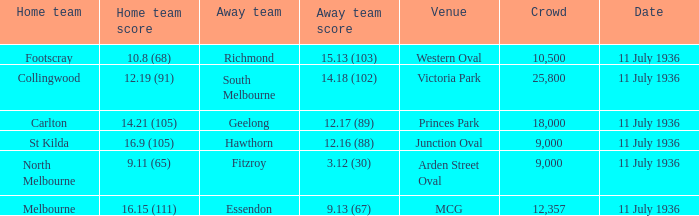What is the lowest crowd seen by the mcg Venue? 12357.0. 